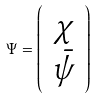<formula> <loc_0><loc_0><loc_500><loc_500>\Psi = \left ( \begin{array} { c } \chi \\ \bar { \psi } \end{array} \right )</formula> 